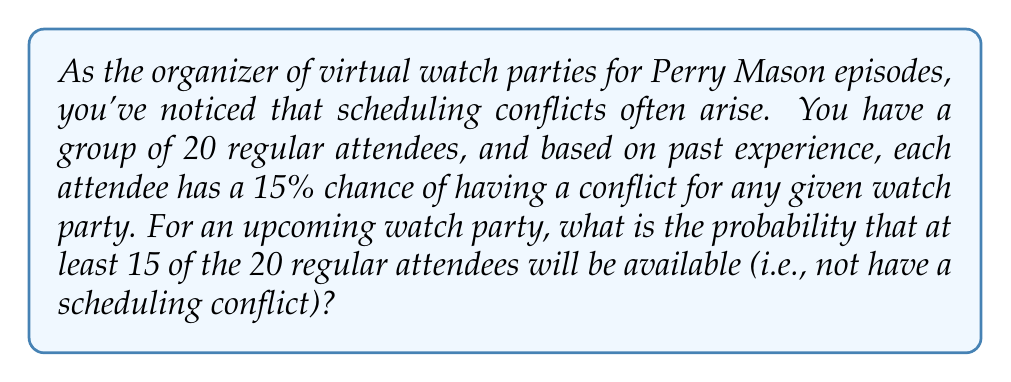Show me your answer to this math problem. Let's approach this step-by-step:

1) First, we need to calculate the probability of an attendee being available. If the probability of having a conflict is 15%, then the probability of being available is:

   $1 - 0.15 = 0.85$ or 85%

2) Now, we're looking for the probability of 15 or more attendees being available out of 20. It's easier to calculate the probability of 14 or fewer being unavailable and then subtract this from 1.

3) This scenario follows a binomial distribution. The probability of exactly $k$ successes in $n$ trials is given by the formula:

   $P(X = k) = \binom{n}{k} p^k (1-p)^{n-k}$

   Where $n$ is the number of trials, $k$ is the number of successes, $p$ is the probability of success on each trial.

4) In our case, $n = 20$, $p = 0.85$, and we need to sum the probabilities for $k = 15$ to $k = 20$.

5) Using the binomial formula:

   $$P(X \geq 15) = \sum_{k=15}^{20} \binom{20}{k} (0.85)^k (0.15)^{20-k}$$

6) Calculating this sum:

   $P(X = 15) = \binom{20}{15} (0.85)^{15} (0.15)^5 = 0.1442$
   $P(X = 16) = \binom{20}{16} (0.85)^{16} (0.15)^4 = 0.2034$
   $P(X = 17) = \binom{20}{17} (0.85)^{17} (0.15)^3 = 0.2272$
   $P(X = 18) = \binom{20}{18} (0.85)^{18} (0.15)^2 = 0.2006$
   $P(X = 19) = \binom{20}{19} (0.85)^{19} (0.15)^1 = 0.1335$
   $P(X = 20) = \binom{20}{20} (0.85)^{20} (0.15)^0 = 0.0388$

7) Summing these probabilities:

   $0.1442 + 0.2034 + 0.2272 + 0.2006 + 0.1335 + 0.0388 = 0.9477$
Answer: The probability that at least 15 of the 20 regular attendees will be available for the upcoming Perry Mason virtual watch party is approximately 0.9477 or 94.77%. 